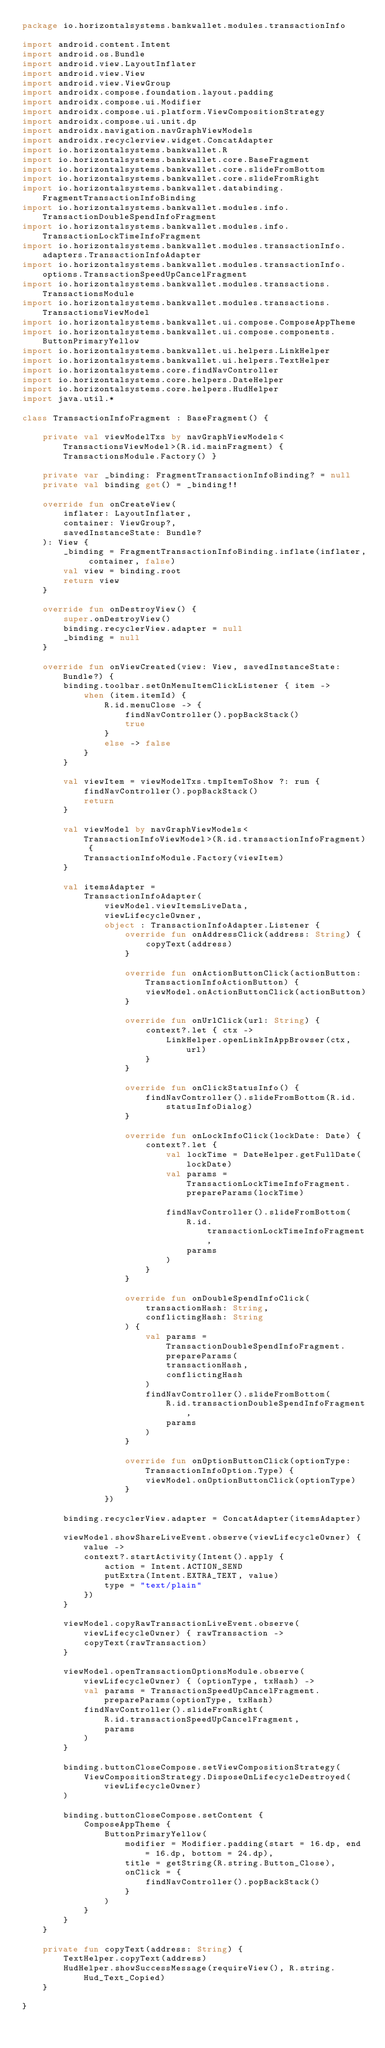<code> <loc_0><loc_0><loc_500><loc_500><_Kotlin_>package io.horizontalsystems.bankwallet.modules.transactionInfo

import android.content.Intent
import android.os.Bundle
import android.view.LayoutInflater
import android.view.View
import android.view.ViewGroup
import androidx.compose.foundation.layout.padding
import androidx.compose.ui.Modifier
import androidx.compose.ui.platform.ViewCompositionStrategy
import androidx.compose.ui.unit.dp
import androidx.navigation.navGraphViewModels
import androidx.recyclerview.widget.ConcatAdapter
import io.horizontalsystems.bankwallet.R
import io.horizontalsystems.bankwallet.core.BaseFragment
import io.horizontalsystems.bankwallet.core.slideFromBottom
import io.horizontalsystems.bankwallet.core.slideFromRight
import io.horizontalsystems.bankwallet.databinding.FragmentTransactionInfoBinding
import io.horizontalsystems.bankwallet.modules.info.TransactionDoubleSpendInfoFragment
import io.horizontalsystems.bankwallet.modules.info.TransactionLockTimeInfoFragment
import io.horizontalsystems.bankwallet.modules.transactionInfo.adapters.TransactionInfoAdapter
import io.horizontalsystems.bankwallet.modules.transactionInfo.options.TransactionSpeedUpCancelFragment
import io.horizontalsystems.bankwallet.modules.transactions.TransactionsModule
import io.horizontalsystems.bankwallet.modules.transactions.TransactionsViewModel
import io.horizontalsystems.bankwallet.ui.compose.ComposeAppTheme
import io.horizontalsystems.bankwallet.ui.compose.components.ButtonPrimaryYellow
import io.horizontalsystems.bankwallet.ui.helpers.LinkHelper
import io.horizontalsystems.bankwallet.ui.helpers.TextHelper
import io.horizontalsystems.core.findNavController
import io.horizontalsystems.core.helpers.DateHelper
import io.horizontalsystems.core.helpers.HudHelper
import java.util.*

class TransactionInfoFragment : BaseFragment() {

    private val viewModelTxs by navGraphViewModels<TransactionsViewModel>(R.id.mainFragment) { TransactionsModule.Factory() }

    private var _binding: FragmentTransactionInfoBinding? = null
    private val binding get() = _binding!!

    override fun onCreateView(
        inflater: LayoutInflater,
        container: ViewGroup?,
        savedInstanceState: Bundle?
    ): View {
        _binding = FragmentTransactionInfoBinding.inflate(inflater, container, false)
        val view = binding.root
        return view
    }

    override fun onDestroyView() {
        super.onDestroyView()
        binding.recyclerView.adapter = null
        _binding = null
    }

    override fun onViewCreated(view: View, savedInstanceState: Bundle?) {
        binding.toolbar.setOnMenuItemClickListener { item ->
            when (item.itemId) {
                R.id.menuClose -> {
                    findNavController().popBackStack()
                    true
                }
                else -> false
            }
        }

        val viewItem = viewModelTxs.tmpItemToShow ?: run {
            findNavController().popBackStack()
            return
        }

        val viewModel by navGraphViewModels<TransactionInfoViewModel>(R.id.transactionInfoFragment) {
            TransactionInfoModule.Factory(viewItem)
        }

        val itemsAdapter =
            TransactionInfoAdapter(
                viewModel.viewItemsLiveData,
                viewLifecycleOwner,
                object : TransactionInfoAdapter.Listener {
                    override fun onAddressClick(address: String) {
                        copyText(address)
                    }

                    override fun onActionButtonClick(actionButton: TransactionInfoActionButton) {
                        viewModel.onActionButtonClick(actionButton)
                    }

                    override fun onUrlClick(url: String) {
                        context?.let { ctx ->
                            LinkHelper.openLinkInAppBrowser(ctx, url)
                        }
                    }

                    override fun onClickStatusInfo() {
                        findNavController().slideFromBottom(R.id.statusInfoDialog)
                    }

                    override fun onLockInfoClick(lockDate: Date) {
                        context?.let {
                            val lockTime = DateHelper.getFullDate(lockDate)
                            val params = TransactionLockTimeInfoFragment.prepareParams(lockTime)

                            findNavController().slideFromBottom(
                                R.id.transactionLockTimeInfoFragment,
                                params
                            )
                        }
                    }

                    override fun onDoubleSpendInfoClick(
                        transactionHash: String,
                        conflictingHash: String
                    ) {
                        val params = TransactionDoubleSpendInfoFragment.prepareParams(
                            transactionHash,
                            conflictingHash
                        )
                        findNavController().slideFromBottom(
                            R.id.transactionDoubleSpendInfoFragment,
                            params
                        )
                    }

                    override fun onOptionButtonClick(optionType: TransactionInfoOption.Type) {
                        viewModel.onOptionButtonClick(optionType)
                    }
                })

        binding.recyclerView.adapter = ConcatAdapter(itemsAdapter)

        viewModel.showShareLiveEvent.observe(viewLifecycleOwner) { value ->
            context?.startActivity(Intent().apply {
                action = Intent.ACTION_SEND
                putExtra(Intent.EXTRA_TEXT, value)
                type = "text/plain"
            })
        }

        viewModel.copyRawTransactionLiveEvent.observe(viewLifecycleOwner) { rawTransaction ->
            copyText(rawTransaction)
        }

        viewModel.openTransactionOptionsModule.observe(viewLifecycleOwner) { (optionType, txHash) ->
            val params = TransactionSpeedUpCancelFragment.prepareParams(optionType, txHash)
            findNavController().slideFromRight(
                R.id.transactionSpeedUpCancelFragment,
                params
            )
        }

        binding.buttonCloseCompose.setViewCompositionStrategy(
            ViewCompositionStrategy.DisposeOnLifecycleDestroyed(viewLifecycleOwner)
        )

        binding.buttonCloseCompose.setContent {
            ComposeAppTheme {
                ButtonPrimaryYellow(
                    modifier = Modifier.padding(start = 16.dp, end = 16.dp, bottom = 24.dp),
                    title = getString(R.string.Button_Close),
                    onClick = {
                        findNavController().popBackStack()
                    }
                )
            }
        }
    }

    private fun copyText(address: String) {
        TextHelper.copyText(address)
        HudHelper.showSuccessMessage(requireView(), R.string.Hud_Text_Copied)
    }

}
</code> 